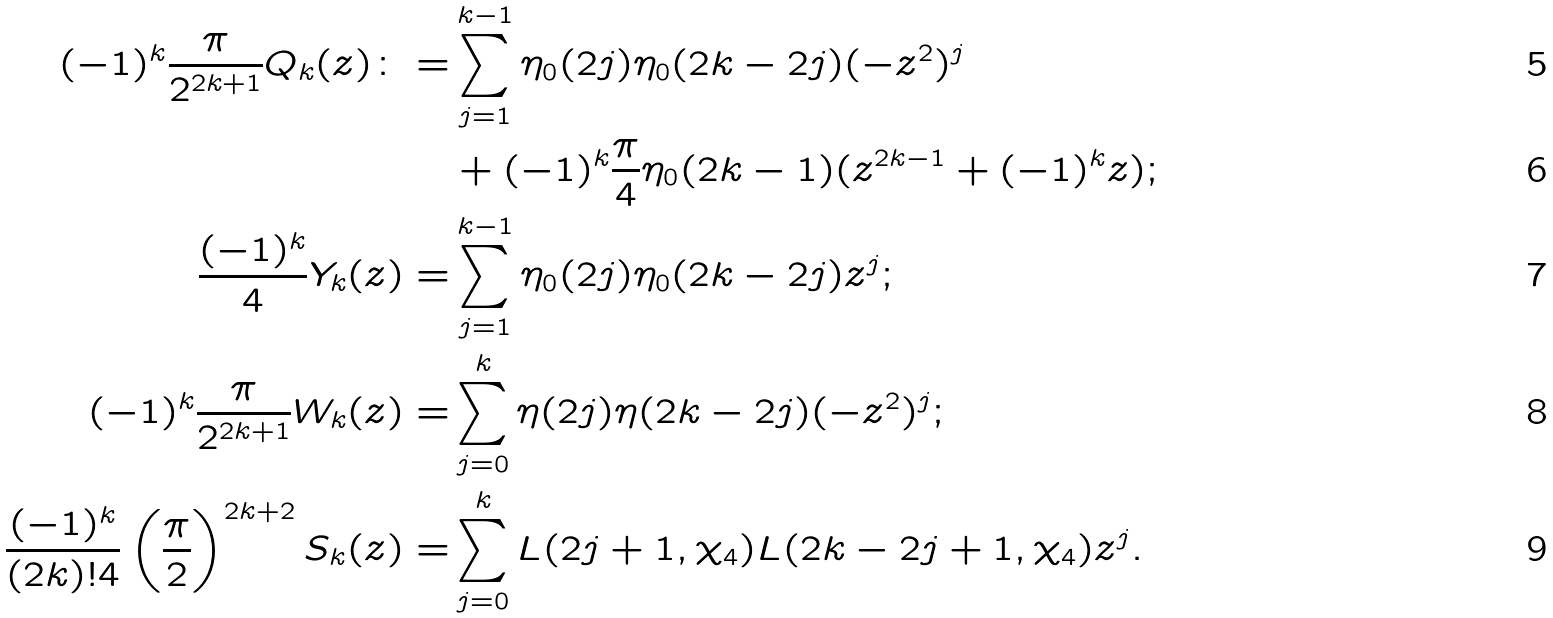<formula> <loc_0><loc_0><loc_500><loc_500>( - 1 ) ^ { k } \frac { \pi } { 2 ^ { 2 k + 1 } } Q _ { k } ( z ) \colon = & \sum _ { j = 1 } ^ { k - 1 } \eta _ { 0 } ( 2 j ) \eta _ { 0 } ( 2 k - 2 j ) ( - z ^ { 2 } ) ^ { j } \\ & + ( - 1 ) ^ { k } \frac { \pi } { 4 } \eta _ { 0 } ( 2 k - 1 ) ( z ^ { 2 k - 1 } + ( - 1 ) ^ { k } z ) ; \\ \frac { ( - 1 ) ^ { k } } { 4 } Y _ { k } ( z ) = & \sum _ { j = 1 } ^ { k - 1 } \eta _ { 0 } ( 2 j ) \eta _ { 0 } ( 2 k - 2 j ) z ^ { j } ; \\ ( - 1 ) ^ { k } \frac { \pi } { 2 ^ { 2 k + 1 } } W _ { k } ( z ) = & \sum _ { j = 0 } ^ { k } \eta ( 2 j ) \eta ( 2 k - 2 j ) ( - z ^ { 2 } ) ^ { j } ; \\ \frac { ( - 1 ) ^ { k } } { ( 2 k ) ! 4 } \left ( \frac { \pi } { 2 } \right ) ^ { 2 k + 2 } S _ { k } ( z ) = & \sum _ { j = 0 } ^ { k } L ( 2 j + 1 , \chi _ { 4 } ) L ( 2 k - 2 j + 1 , \chi _ { 4 } ) z ^ { j } .</formula> 